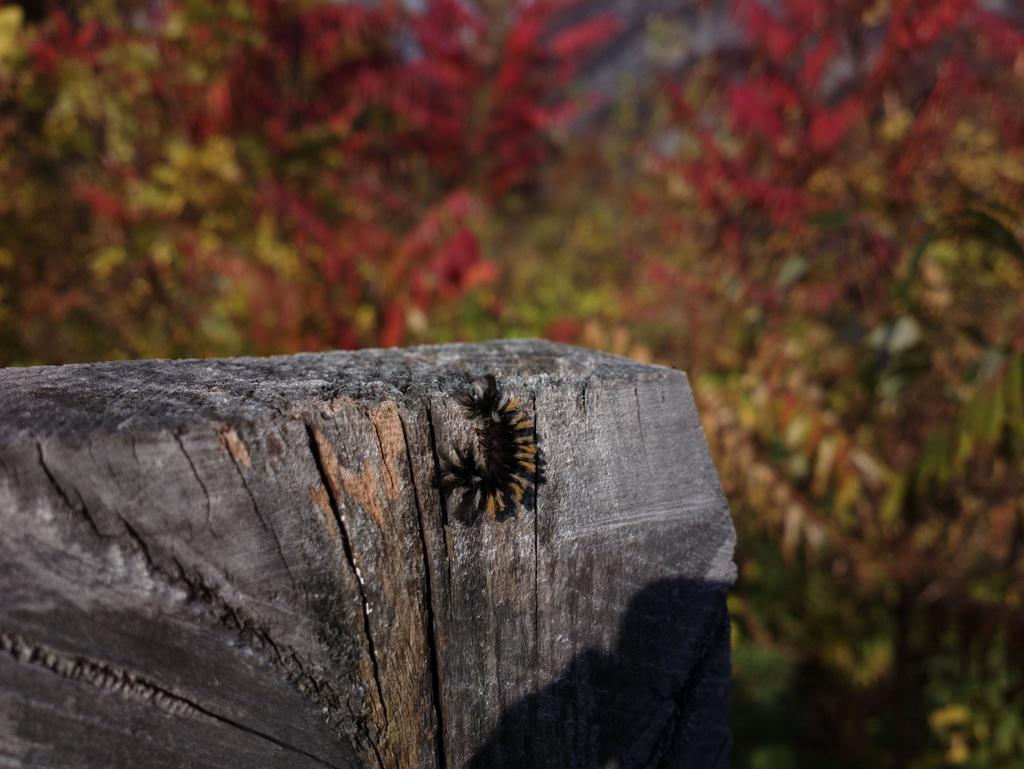What is on the wooden surface in the image? There is an insect on a wooden surface in the image. How would you describe the background of the image? The background of the image is blurred. What can be seen in the blurred background? Trees are present in the blurred background of the image. What type of guitar is being played in the plantation in the image? There is no guitar or plantation present in the image; it features an insect on a wooden surface with a blurred background containing trees. 